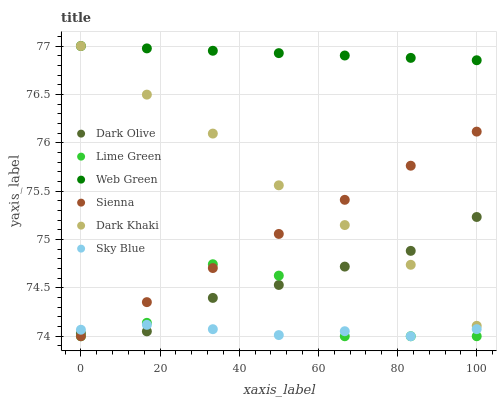Does Sky Blue have the minimum area under the curve?
Answer yes or no. Yes. Does Web Green have the maximum area under the curve?
Answer yes or no. Yes. Does Dark Olive have the minimum area under the curve?
Answer yes or no. No. Does Dark Olive have the maximum area under the curve?
Answer yes or no. No. Is Sienna the smoothest?
Answer yes or no. Yes. Is Lime Green the roughest?
Answer yes or no. Yes. Is Dark Olive the smoothest?
Answer yes or no. No. Is Dark Olive the roughest?
Answer yes or no. No. Does Sienna have the lowest value?
Answer yes or no. Yes. Does Dark Olive have the lowest value?
Answer yes or no. No. Does Web Green have the highest value?
Answer yes or no. Yes. Does Dark Olive have the highest value?
Answer yes or no. No. Is Sienna less than Web Green?
Answer yes or no. Yes. Is Web Green greater than Sky Blue?
Answer yes or no. Yes. Does Lime Green intersect Sky Blue?
Answer yes or no. Yes. Is Lime Green less than Sky Blue?
Answer yes or no. No. Is Lime Green greater than Sky Blue?
Answer yes or no. No. Does Sienna intersect Web Green?
Answer yes or no. No. 